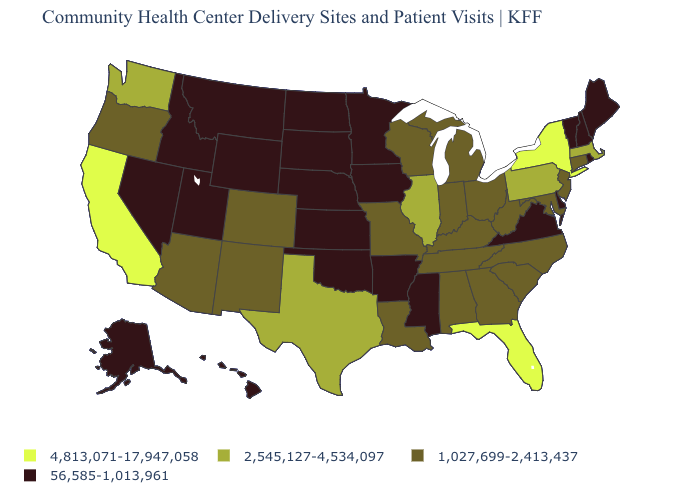Name the states that have a value in the range 4,813,071-17,947,058?
Quick response, please. California, Florida, New York. What is the value of Georgia?
Concise answer only. 1,027,699-2,413,437. What is the value of Montana?
Answer briefly. 56,585-1,013,961. Among the states that border Maryland , which have the highest value?
Quick response, please. Pennsylvania. How many symbols are there in the legend?
Quick response, please. 4. Name the states that have a value in the range 2,545,127-4,534,097?
Give a very brief answer. Illinois, Massachusetts, Pennsylvania, Texas, Washington. Name the states that have a value in the range 4,813,071-17,947,058?
Be succinct. California, Florida, New York. What is the highest value in the USA?
Keep it brief. 4,813,071-17,947,058. Does Wyoming have the same value as Nebraska?
Give a very brief answer. Yes. Among the states that border Louisiana , which have the lowest value?
Short answer required. Arkansas, Mississippi. How many symbols are there in the legend?
Give a very brief answer. 4. Among the states that border Louisiana , does Mississippi have the lowest value?
Short answer required. Yes. Which states have the lowest value in the USA?
Give a very brief answer. Alaska, Arkansas, Delaware, Hawaii, Idaho, Iowa, Kansas, Maine, Minnesota, Mississippi, Montana, Nebraska, Nevada, New Hampshire, North Dakota, Oklahoma, Rhode Island, South Dakota, Utah, Vermont, Virginia, Wyoming. Which states hav the highest value in the MidWest?
Give a very brief answer. Illinois. Name the states that have a value in the range 4,813,071-17,947,058?
Keep it brief. California, Florida, New York. 